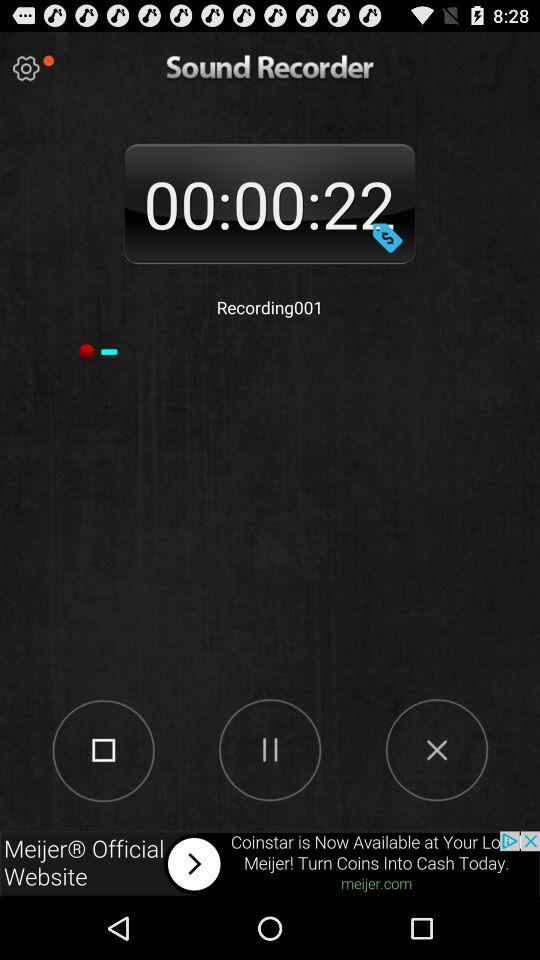How many seconds are in the recording?
Answer the question using a single word or phrase. 22 